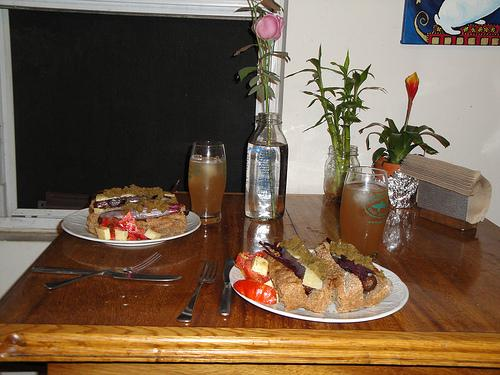Choose the correct option: The beverage on the table is a glass of (a) beer, (b) iced tea or (c) water. (b) iced tea Describe the setting of the image in a brief sentence. A cozy dinner table for two people with a meal, drinks, and a flower, placed next to a window with a screen closed. Which of the following objects is on the wall: (a) poster, (b) mirror, or (c) clock? (a) poster Based on the image, what type of meal is being served on the wooden table? A sausage-based meal, possibly with some shellfish like crawfish on toast. Is there anything suggesting that the people eating are eating at home? Yes, there's a window beside the table with the screen closed, a TV in the background, and a picture on the wall, indicating a homely setting. In your own words, briefly describe the decorations present on the table. The table is adorned with a beautiful rose in a clear glass bottle, some potted plants, and brown napkins in a napkin holder. Describe the location of the silverware on the table. The silverware is placed on the table near the plate with the fork next to a knife and a knife next to the plate. Mention the items that can be classified as "glasses" in the image. A glass with ice in it, a glass of beer, a clear glass bottle, a glass of iced tea, and a vase for the rose which is actually a drink bottle. Identify the primary objects on the table for a dinner setup. A plate with dinner, two hot dogs, silverware, a glass with ice, a glass of beer, a flower, and brown napkins in a holder. 